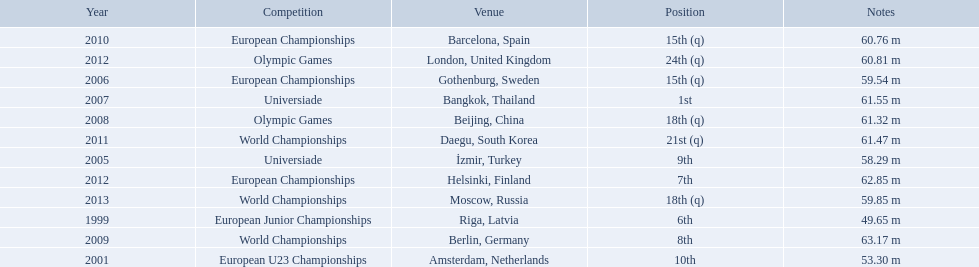Could you parse the entire table as a dict? {'header': ['Year', 'Competition', 'Venue', 'Position', 'Notes'], 'rows': [['2010', 'European Championships', 'Barcelona, Spain', '15th (q)', '60.76 m'], ['2012', 'Olympic Games', 'London, United Kingdom', '24th (q)', '60.81 m'], ['2006', 'European Championships', 'Gothenburg, Sweden', '15th (q)', '59.54 m'], ['2007', 'Universiade', 'Bangkok, Thailand', '1st', '61.55 m'], ['2008', 'Olympic Games', 'Beijing, China', '18th (q)', '61.32 m'], ['2011', 'World Championships', 'Daegu, South Korea', '21st (q)', '61.47 m'], ['2005', 'Universiade', 'İzmir, Turkey', '9th', '58.29 m'], ['2012', 'European Championships', 'Helsinki, Finland', '7th', '62.85 m'], ['2013', 'World Championships', 'Moscow, Russia', '18th (q)', '59.85 m'], ['1999', 'European Junior Championships', 'Riga, Latvia', '6th', '49.65 m'], ['2009', 'World Championships', 'Berlin, Germany', '8th', '63.17 m'], ['2001', 'European U23 Championships', 'Amsterdam, Netherlands', '10th', '53.30 m']]} What european junior championships? 6th. What waseuropean junior championships best result? 63.17 m. 